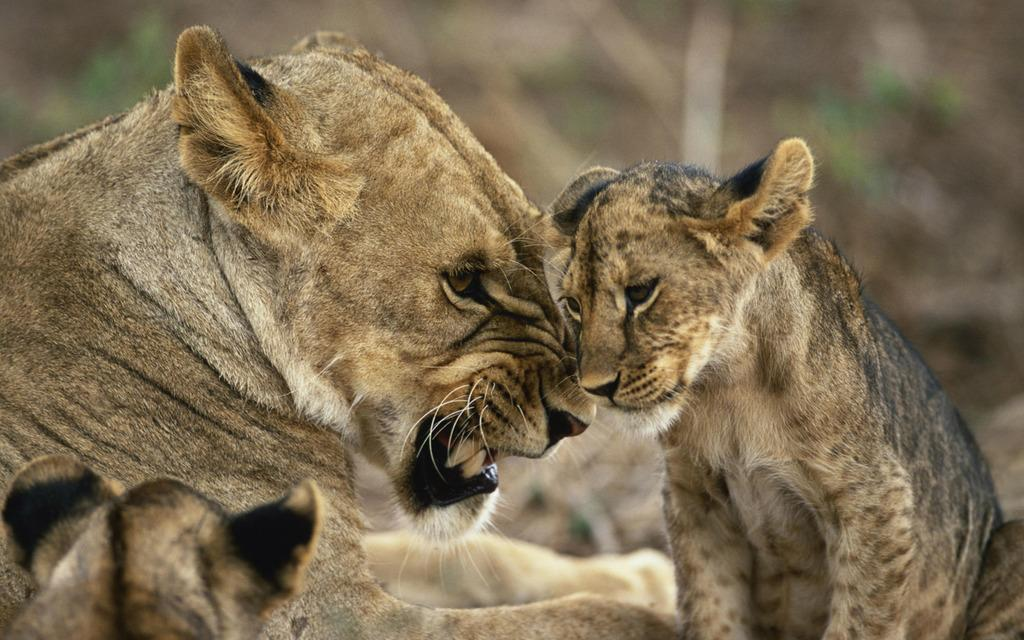What type of animal is the main subject of the picture? There is a lion in the picture. Are there any other animals or creatures in the picture? Yes, there are cubs present in the picture. What time of day is the lion performing on stage in the picture? There is no stage or performance in the picture; it simply features a lion and cubs. What type of range is visible in the background of the picture? There is no range visible in the picture; it only shows a lion and cubs. 